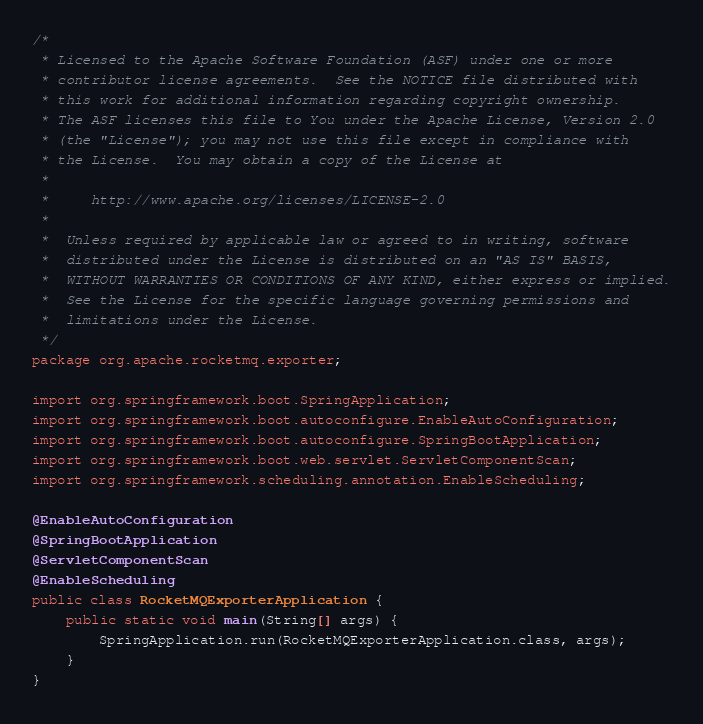<code> <loc_0><loc_0><loc_500><loc_500><_Java_>/*
 * Licensed to the Apache Software Foundation (ASF) under one or more
 * contributor license agreements.  See the NOTICE file distributed with
 * this work for additional information regarding copyright ownership.
 * The ASF licenses this file to You under the Apache License, Version 2.0
 * (the "License"); you may not use this file except in compliance with
 * the License.  You may obtain a copy of the License at
 *
 *     http://www.apache.org/licenses/LICENSE-2.0
 *
 *  Unless required by applicable law or agreed to in writing, software
 *  distributed under the License is distributed on an "AS IS" BASIS,
 *  WITHOUT WARRANTIES OR CONDITIONS OF ANY KIND, either express or implied.
 *  See the License for the specific language governing permissions and
 *  limitations under the License.
 */
package org.apache.rocketmq.exporter;

import org.springframework.boot.SpringApplication;
import org.springframework.boot.autoconfigure.EnableAutoConfiguration;
import org.springframework.boot.autoconfigure.SpringBootApplication;
import org.springframework.boot.web.servlet.ServletComponentScan;
import org.springframework.scheduling.annotation.EnableScheduling;

@EnableAutoConfiguration
@SpringBootApplication
@ServletComponentScan
@EnableScheduling
public class RocketMQExporterApplication {
    public static void main(String[] args) {
        SpringApplication.run(RocketMQExporterApplication.class, args);
    }
}


</code> 